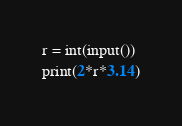<code> <loc_0><loc_0><loc_500><loc_500><_Python_>r = int(input())
print(2*r*3.14)</code> 